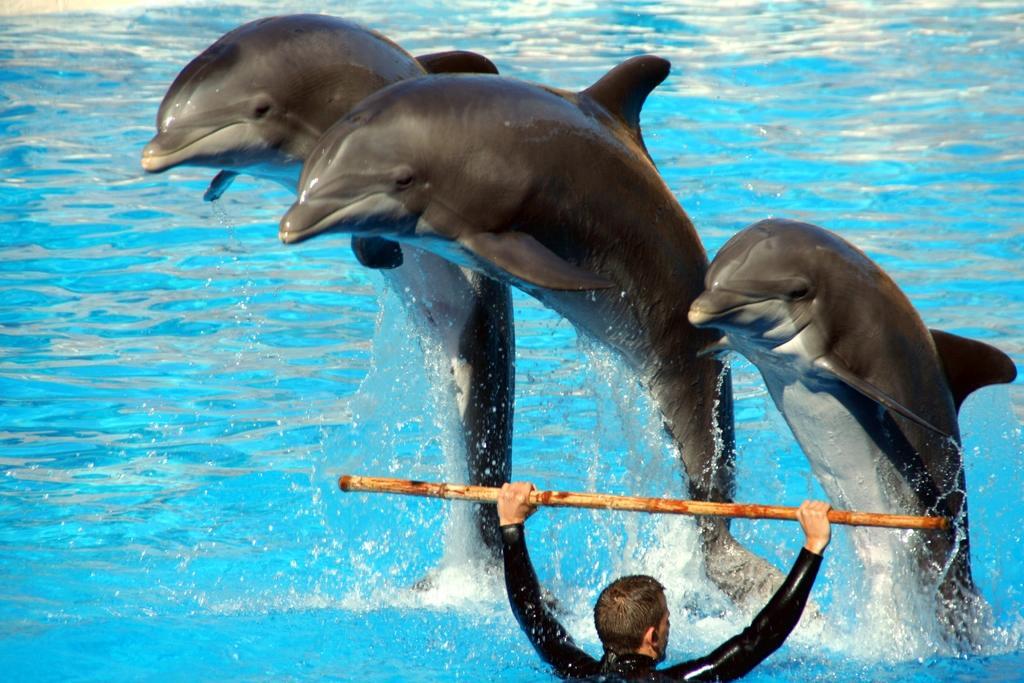How would you summarize this image in a sentence or two? In this image we can see dolphins, water, and a person holding a stick with his hands. 